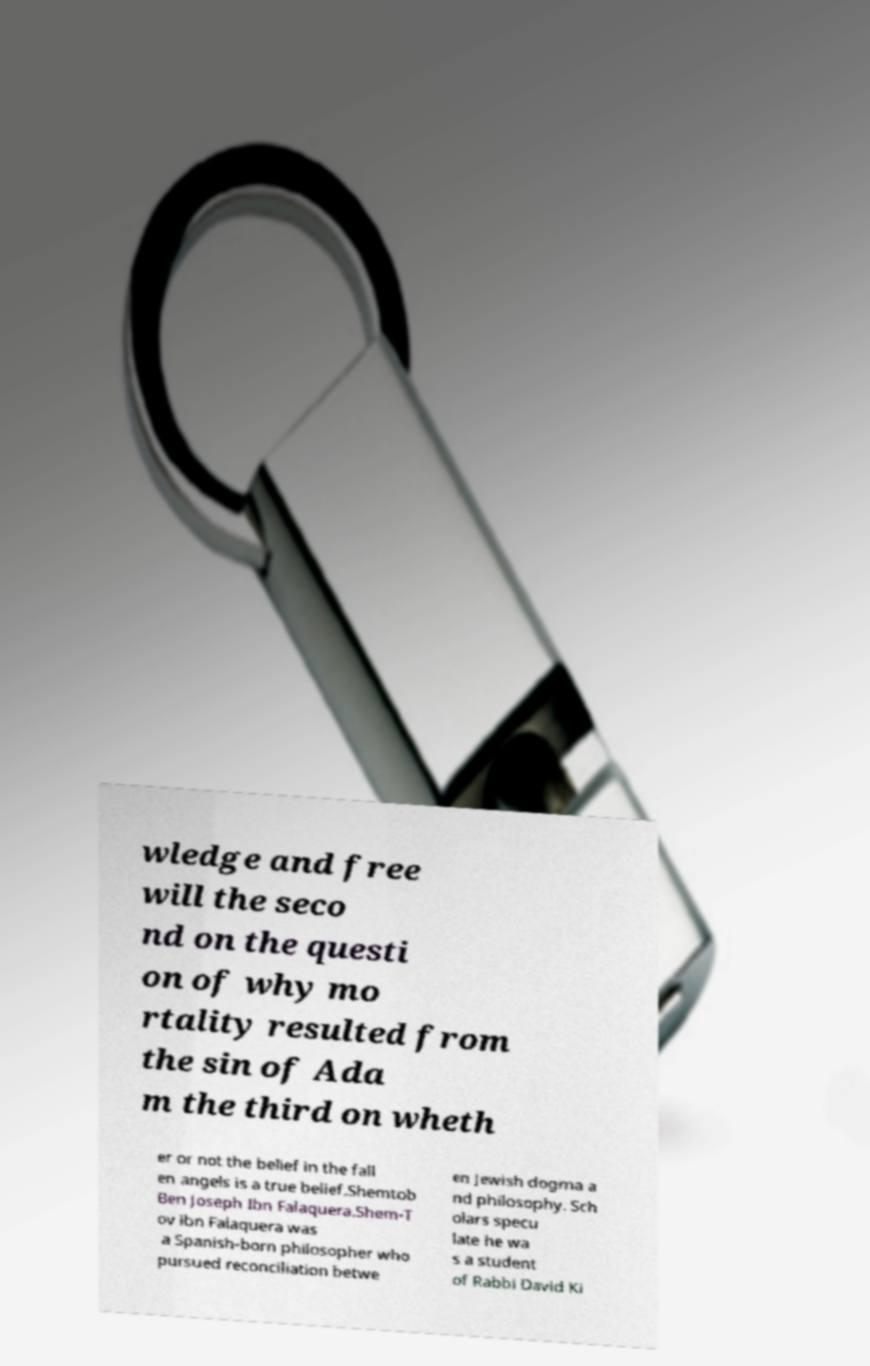For documentation purposes, I need the text within this image transcribed. Could you provide that? wledge and free will the seco nd on the questi on of why mo rtality resulted from the sin of Ada m the third on wheth er or not the belief in the fall en angels is a true belief.Shemtob Ben Joseph Ibn Falaquera.Shem-T ov ibn Falaquera was a Spanish-born philosopher who pursued reconciliation betwe en Jewish dogma a nd philosophy. Sch olars specu late he wa s a student of Rabbi David Ki 